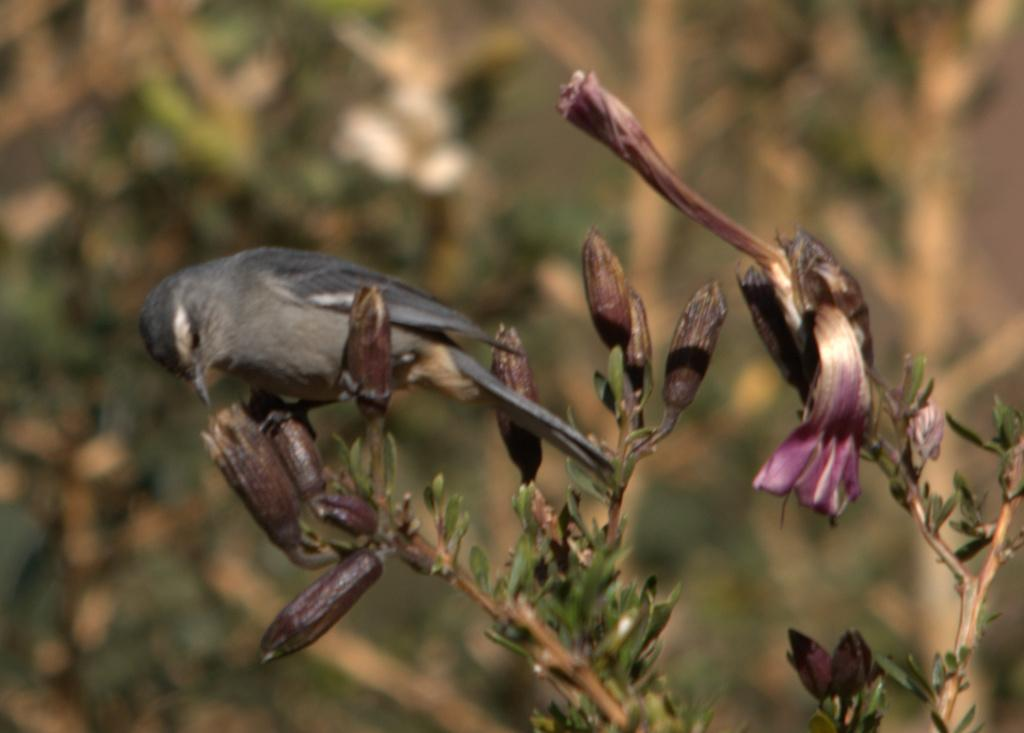What type of animal can be seen in the image? There is a bird in the image. Where is the bird located? The bird is on a plant. Can you describe the background of the image? The background of the image is blurred. What substance is the bird holding in its hands in the image? The bird does not have hands, and there is no substance visible in the image. 